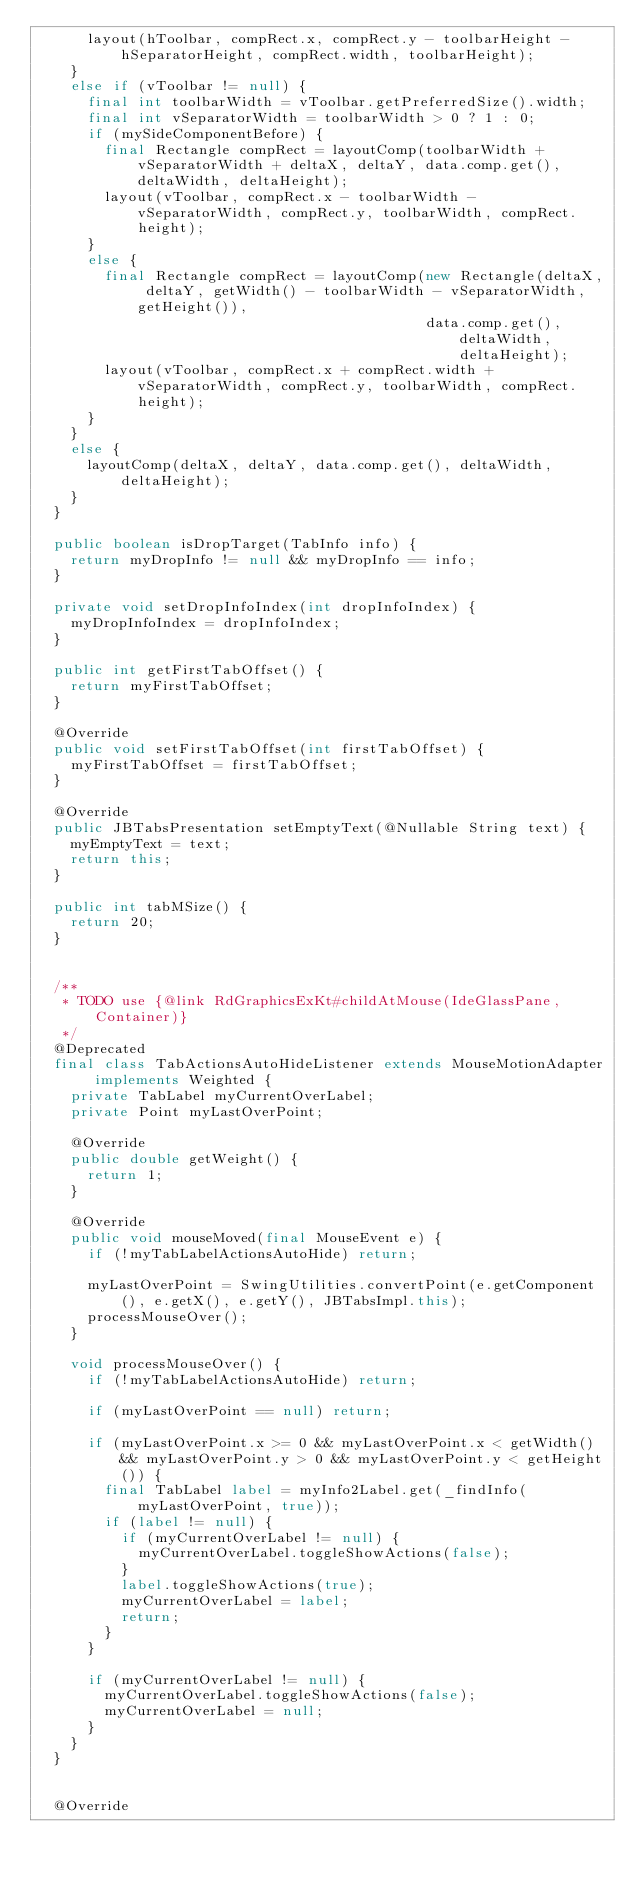<code> <loc_0><loc_0><loc_500><loc_500><_Java_>      layout(hToolbar, compRect.x, compRect.y - toolbarHeight - hSeparatorHeight, compRect.width, toolbarHeight);
    }
    else if (vToolbar != null) {
      final int toolbarWidth = vToolbar.getPreferredSize().width;
      final int vSeparatorWidth = toolbarWidth > 0 ? 1 : 0;
      if (mySideComponentBefore) {
        final Rectangle compRect = layoutComp(toolbarWidth + vSeparatorWidth + deltaX, deltaY, data.comp.get(), deltaWidth, deltaHeight);
        layout(vToolbar, compRect.x - toolbarWidth - vSeparatorWidth, compRect.y, toolbarWidth, compRect.height);
      }
      else {
        final Rectangle compRect = layoutComp(new Rectangle(deltaX, deltaY, getWidth() - toolbarWidth - vSeparatorWidth, getHeight()),
                                              data.comp.get(), deltaWidth, deltaHeight);
        layout(vToolbar, compRect.x + compRect.width + vSeparatorWidth, compRect.y, toolbarWidth, compRect.height);
      }
    }
    else {
      layoutComp(deltaX, deltaY, data.comp.get(), deltaWidth, deltaHeight);
    }
  }

  public boolean isDropTarget(TabInfo info) {
    return myDropInfo != null && myDropInfo == info;
  }

  private void setDropInfoIndex(int dropInfoIndex) {
    myDropInfoIndex = dropInfoIndex;
  }

  public int getFirstTabOffset() {
    return myFirstTabOffset;
  }

  @Override
  public void setFirstTabOffset(int firstTabOffset) {
    myFirstTabOffset = firstTabOffset;
  }

  @Override
  public JBTabsPresentation setEmptyText(@Nullable String text) {
    myEmptyText = text;
    return this;
  }

  public int tabMSize() {
    return 20;
  }


  /**
   * TODO use {@link RdGraphicsExKt#childAtMouse(IdeGlassPane, Container)}
   */
  @Deprecated
  final class TabActionsAutoHideListener extends MouseMotionAdapter implements Weighted {
    private TabLabel myCurrentOverLabel;
    private Point myLastOverPoint;

    @Override
    public double getWeight() {
      return 1;
    }

    @Override
    public void mouseMoved(final MouseEvent e) {
      if (!myTabLabelActionsAutoHide) return;

      myLastOverPoint = SwingUtilities.convertPoint(e.getComponent(), e.getX(), e.getY(), JBTabsImpl.this);
      processMouseOver();
    }

    void processMouseOver() {
      if (!myTabLabelActionsAutoHide) return;

      if (myLastOverPoint == null) return;

      if (myLastOverPoint.x >= 0 && myLastOverPoint.x < getWidth() && myLastOverPoint.y > 0 && myLastOverPoint.y < getHeight()) {
        final TabLabel label = myInfo2Label.get(_findInfo(myLastOverPoint, true));
        if (label != null) {
          if (myCurrentOverLabel != null) {
            myCurrentOverLabel.toggleShowActions(false);
          }
          label.toggleShowActions(true);
          myCurrentOverLabel = label;
          return;
        }
      }

      if (myCurrentOverLabel != null) {
        myCurrentOverLabel.toggleShowActions(false);
        myCurrentOverLabel = null;
      }
    }
  }


  @Override</code> 